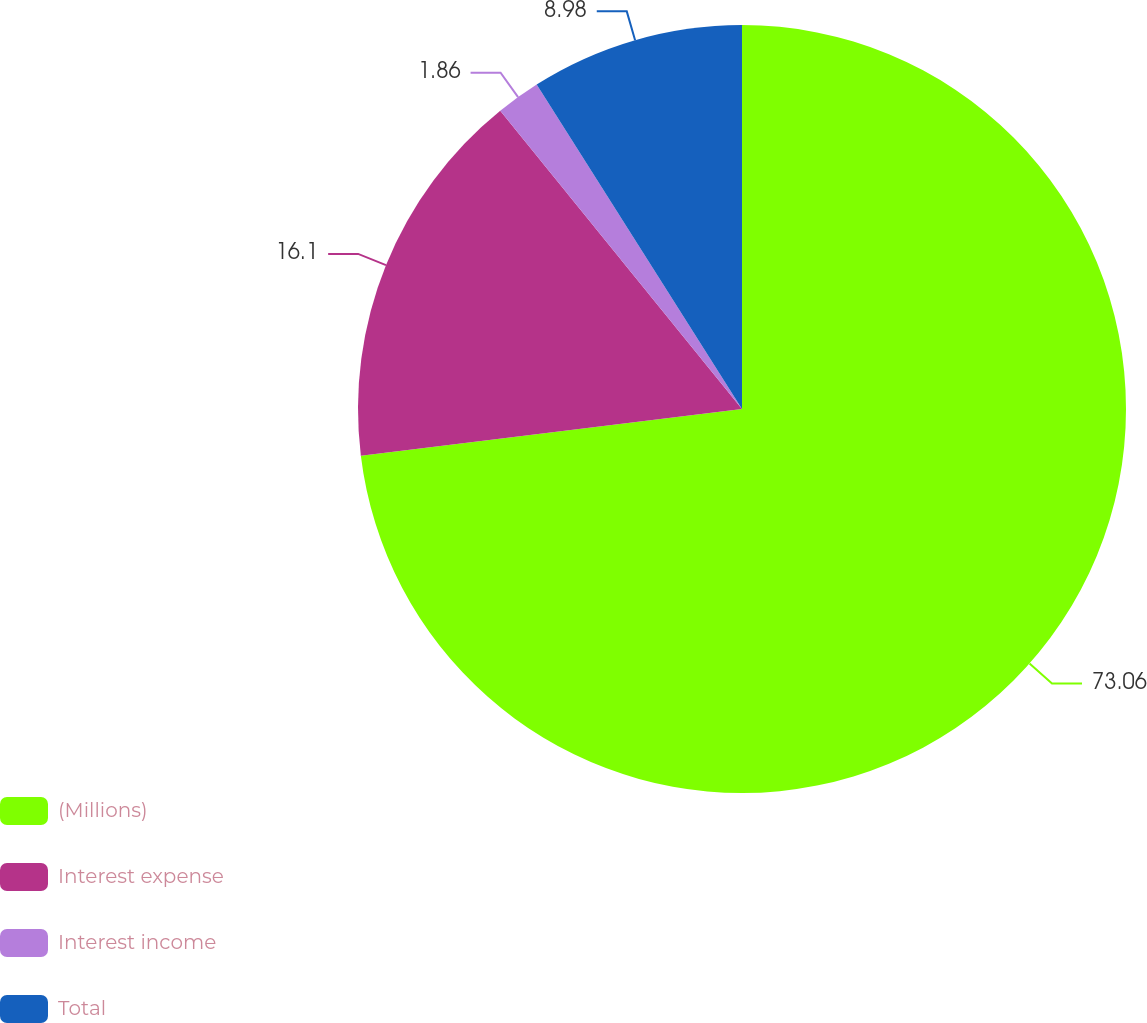Convert chart. <chart><loc_0><loc_0><loc_500><loc_500><pie_chart><fcel>(Millions)<fcel>Interest expense<fcel>Interest income<fcel>Total<nl><fcel>73.07%<fcel>16.1%<fcel>1.86%<fcel>8.98%<nl></chart> 